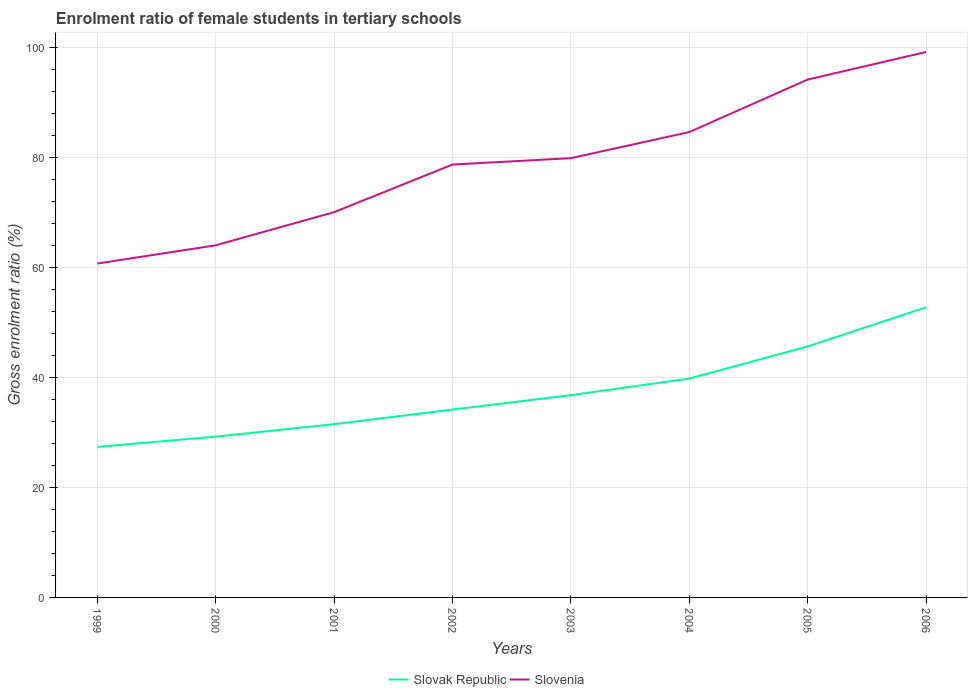How many different coloured lines are there?
Your answer should be compact. 2. Does the line corresponding to Slovak Republic intersect with the line corresponding to Slovenia?
Make the answer very short. No. Across all years, what is the maximum enrolment ratio of female students in tertiary schools in Slovenia?
Make the answer very short. 60.68. In which year was the enrolment ratio of female students in tertiary schools in Slovak Republic maximum?
Your response must be concise. 1999. What is the total enrolment ratio of female students in tertiary schools in Slovenia in the graph?
Make the answer very short. -17.99. What is the difference between the highest and the second highest enrolment ratio of female students in tertiary schools in Slovenia?
Make the answer very short. 38.45. What is the difference between the highest and the lowest enrolment ratio of female students in tertiary schools in Slovak Republic?
Keep it short and to the point. 3. Is the enrolment ratio of female students in tertiary schools in Slovak Republic strictly greater than the enrolment ratio of female students in tertiary schools in Slovenia over the years?
Keep it short and to the point. Yes. How many lines are there?
Provide a short and direct response. 2. How many years are there in the graph?
Offer a very short reply. 8. Does the graph contain any zero values?
Your answer should be very brief. No. How are the legend labels stacked?
Ensure brevity in your answer.  Horizontal. What is the title of the graph?
Give a very brief answer. Enrolment ratio of female students in tertiary schools. Does "Seychelles" appear as one of the legend labels in the graph?
Offer a very short reply. No. What is the label or title of the X-axis?
Ensure brevity in your answer.  Years. What is the Gross enrolment ratio (%) in Slovak Republic in 1999?
Ensure brevity in your answer.  27.36. What is the Gross enrolment ratio (%) of Slovenia in 1999?
Keep it short and to the point. 60.68. What is the Gross enrolment ratio (%) in Slovak Republic in 2000?
Keep it short and to the point. 29.23. What is the Gross enrolment ratio (%) in Slovenia in 2000?
Give a very brief answer. 64. What is the Gross enrolment ratio (%) of Slovak Republic in 2001?
Make the answer very short. 31.49. What is the Gross enrolment ratio (%) of Slovenia in 2001?
Offer a terse response. 70.02. What is the Gross enrolment ratio (%) of Slovak Republic in 2002?
Ensure brevity in your answer.  34.15. What is the Gross enrolment ratio (%) in Slovenia in 2002?
Make the answer very short. 78.68. What is the Gross enrolment ratio (%) in Slovak Republic in 2003?
Provide a succinct answer. 36.76. What is the Gross enrolment ratio (%) in Slovenia in 2003?
Offer a terse response. 79.84. What is the Gross enrolment ratio (%) in Slovak Republic in 2004?
Provide a succinct answer. 39.78. What is the Gross enrolment ratio (%) in Slovenia in 2004?
Offer a very short reply. 84.58. What is the Gross enrolment ratio (%) of Slovak Republic in 2005?
Offer a terse response. 45.62. What is the Gross enrolment ratio (%) of Slovenia in 2005?
Provide a succinct answer. 94.12. What is the Gross enrolment ratio (%) in Slovak Republic in 2006?
Offer a terse response. 52.73. What is the Gross enrolment ratio (%) of Slovenia in 2006?
Give a very brief answer. 99.13. Across all years, what is the maximum Gross enrolment ratio (%) in Slovak Republic?
Provide a succinct answer. 52.73. Across all years, what is the maximum Gross enrolment ratio (%) of Slovenia?
Your answer should be compact. 99.13. Across all years, what is the minimum Gross enrolment ratio (%) of Slovak Republic?
Provide a succinct answer. 27.36. Across all years, what is the minimum Gross enrolment ratio (%) in Slovenia?
Make the answer very short. 60.68. What is the total Gross enrolment ratio (%) in Slovak Republic in the graph?
Offer a very short reply. 297.11. What is the total Gross enrolment ratio (%) of Slovenia in the graph?
Provide a short and direct response. 631.05. What is the difference between the Gross enrolment ratio (%) in Slovak Republic in 1999 and that in 2000?
Your answer should be compact. -1.87. What is the difference between the Gross enrolment ratio (%) of Slovenia in 1999 and that in 2000?
Keep it short and to the point. -3.32. What is the difference between the Gross enrolment ratio (%) in Slovak Republic in 1999 and that in 2001?
Your answer should be compact. -4.14. What is the difference between the Gross enrolment ratio (%) in Slovenia in 1999 and that in 2001?
Make the answer very short. -9.34. What is the difference between the Gross enrolment ratio (%) of Slovak Republic in 1999 and that in 2002?
Keep it short and to the point. -6.79. What is the difference between the Gross enrolment ratio (%) of Slovenia in 1999 and that in 2002?
Ensure brevity in your answer.  -17.99. What is the difference between the Gross enrolment ratio (%) of Slovak Republic in 1999 and that in 2003?
Provide a succinct answer. -9.41. What is the difference between the Gross enrolment ratio (%) in Slovenia in 1999 and that in 2003?
Provide a succinct answer. -19.16. What is the difference between the Gross enrolment ratio (%) in Slovak Republic in 1999 and that in 2004?
Keep it short and to the point. -12.43. What is the difference between the Gross enrolment ratio (%) of Slovenia in 1999 and that in 2004?
Your answer should be very brief. -23.9. What is the difference between the Gross enrolment ratio (%) in Slovak Republic in 1999 and that in 2005?
Provide a succinct answer. -18.26. What is the difference between the Gross enrolment ratio (%) of Slovenia in 1999 and that in 2005?
Give a very brief answer. -33.44. What is the difference between the Gross enrolment ratio (%) in Slovak Republic in 1999 and that in 2006?
Offer a very short reply. -25.37. What is the difference between the Gross enrolment ratio (%) in Slovenia in 1999 and that in 2006?
Ensure brevity in your answer.  -38.45. What is the difference between the Gross enrolment ratio (%) of Slovak Republic in 2000 and that in 2001?
Provide a succinct answer. -2.26. What is the difference between the Gross enrolment ratio (%) of Slovenia in 2000 and that in 2001?
Offer a very short reply. -6.02. What is the difference between the Gross enrolment ratio (%) in Slovak Republic in 2000 and that in 2002?
Your answer should be very brief. -4.92. What is the difference between the Gross enrolment ratio (%) of Slovenia in 2000 and that in 2002?
Your response must be concise. -14.68. What is the difference between the Gross enrolment ratio (%) in Slovak Republic in 2000 and that in 2003?
Provide a succinct answer. -7.53. What is the difference between the Gross enrolment ratio (%) of Slovenia in 2000 and that in 2003?
Provide a short and direct response. -15.84. What is the difference between the Gross enrolment ratio (%) in Slovak Republic in 2000 and that in 2004?
Provide a succinct answer. -10.55. What is the difference between the Gross enrolment ratio (%) of Slovenia in 2000 and that in 2004?
Ensure brevity in your answer.  -20.58. What is the difference between the Gross enrolment ratio (%) in Slovak Republic in 2000 and that in 2005?
Offer a very short reply. -16.39. What is the difference between the Gross enrolment ratio (%) in Slovenia in 2000 and that in 2005?
Your response must be concise. -30.12. What is the difference between the Gross enrolment ratio (%) in Slovak Republic in 2000 and that in 2006?
Offer a very short reply. -23.5. What is the difference between the Gross enrolment ratio (%) in Slovenia in 2000 and that in 2006?
Your response must be concise. -35.13. What is the difference between the Gross enrolment ratio (%) of Slovak Republic in 2001 and that in 2002?
Your answer should be very brief. -2.65. What is the difference between the Gross enrolment ratio (%) in Slovenia in 2001 and that in 2002?
Your response must be concise. -8.65. What is the difference between the Gross enrolment ratio (%) in Slovak Republic in 2001 and that in 2003?
Provide a succinct answer. -5.27. What is the difference between the Gross enrolment ratio (%) of Slovenia in 2001 and that in 2003?
Make the answer very short. -9.82. What is the difference between the Gross enrolment ratio (%) of Slovak Republic in 2001 and that in 2004?
Keep it short and to the point. -8.29. What is the difference between the Gross enrolment ratio (%) in Slovenia in 2001 and that in 2004?
Ensure brevity in your answer.  -14.56. What is the difference between the Gross enrolment ratio (%) in Slovak Republic in 2001 and that in 2005?
Your response must be concise. -14.13. What is the difference between the Gross enrolment ratio (%) in Slovenia in 2001 and that in 2005?
Provide a succinct answer. -24.1. What is the difference between the Gross enrolment ratio (%) of Slovak Republic in 2001 and that in 2006?
Offer a terse response. -21.24. What is the difference between the Gross enrolment ratio (%) in Slovenia in 2001 and that in 2006?
Your response must be concise. -29.11. What is the difference between the Gross enrolment ratio (%) of Slovak Republic in 2002 and that in 2003?
Provide a short and direct response. -2.62. What is the difference between the Gross enrolment ratio (%) in Slovenia in 2002 and that in 2003?
Your answer should be very brief. -1.16. What is the difference between the Gross enrolment ratio (%) of Slovak Republic in 2002 and that in 2004?
Make the answer very short. -5.64. What is the difference between the Gross enrolment ratio (%) of Slovenia in 2002 and that in 2004?
Provide a succinct answer. -5.9. What is the difference between the Gross enrolment ratio (%) in Slovak Republic in 2002 and that in 2005?
Provide a short and direct response. -11.47. What is the difference between the Gross enrolment ratio (%) of Slovenia in 2002 and that in 2005?
Offer a very short reply. -15.44. What is the difference between the Gross enrolment ratio (%) in Slovak Republic in 2002 and that in 2006?
Provide a short and direct response. -18.58. What is the difference between the Gross enrolment ratio (%) of Slovenia in 2002 and that in 2006?
Give a very brief answer. -20.46. What is the difference between the Gross enrolment ratio (%) of Slovak Republic in 2003 and that in 2004?
Provide a short and direct response. -3.02. What is the difference between the Gross enrolment ratio (%) in Slovenia in 2003 and that in 2004?
Offer a very short reply. -4.74. What is the difference between the Gross enrolment ratio (%) in Slovak Republic in 2003 and that in 2005?
Provide a succinct answer. -8.86. What is the difference between the Gross enrolment ratio (%) in Slovenia in 2003 and that in 2005?
Make the answer very short. -14.28. What is the difference between the Gross enrolment ratio (%) in Slovak Republic in 2003 and that in 2006?
Keep it short and to the point. -15.97. What is the difference between the Gross enrolment ratio (%) of Slovenia in 2003 and that in 2006?
Your answer should be compact. -19.29. What is the difference between the Gross enrolment ratio (%) of Slovak Republic in 2004 and that in 2005?
Give a very brief answer. -5.84. What is the difference between the Gross enrolment ratio (%) in Slovenia in 2004 and that in 2005?
Offer a terse response. -9.54. What is the difference between the Gross enrolment ratio (%) in Slovak Republic in 2004 and that in 2006?
Offer a terse response. -12.95. What is the difference between the Gross enrolment ratio (%) in Slovenia in 2004 and that in 2006?
Your response must be concise. -14.55. What is the difference between the Gross enrolment ratio (%) in Slovak Republic in 2005 and that in 2006?
Keep it short and to the point. -7.11. What is the difference between the Gross enrolment ratio (%) in Slovenia in 2005 and that in 2006?
Give a very brief answer. -5.01. What is the difference between the Gross enrolment ratio (%) in Slovak Republic in 1999 and the Gross enrolment ratio (%) in Slovenia in 2000?
Your response must be concise. -36.64. What is the difference between the Gross enrolment ratio (%) in Slovak Republic in 1999 and the Gross enrolment ratio (%) in Slovenia in 2001?
Your answer should be very brief. -42.67. What is the difference between the Gross enrolment ratio (%) in Slovak Republic in 1999 and the Gross enrolment ratio (%) in Slovenia in 2002?
Ensure brevity in your answer.  -51.32. What is the difference between the Gross enrolment ratio (%) of Slovak Republic in 1999 and the Gross enrolment ratio (%) of Slovenia in 2003?
Provide a short and direct response. -52.48. What is the difference between the Gross enrolment ratio (%) of Slovak Republic in 1999 and the Gross enrolment ratio (%) of Slovenia in 2004?
Ensure brevity in your answer.  -57.22. What is the difference between the Gross enrolment ratio (%) of Slovak Republic in 1999 and the Gross enrolment ratio (%) of Slovenia in 2005?
Give a very brief answer. -66.77. What is the difference between the Gross enrolment ratio (%) of Slovak Republic in 1999 and the Gross enrolment ratio (%) of Slovenia in 2006?
Your answer should be compact. -71.78. What is the difference between the Gross enrolment ratio (%) in Slovak Republic in 2000 and the Gross enrolment ratio (%) in Slovenia in 2001?
Your answer should be compact. -40.8. What is the difference between the Gross enrolment ratio (%) in Slovak Republic in 2000 and the Gross enrolment ratio (%) in Slovenia in 2002?
Offer a very short reply. -49.45. What is the difference between the Gross enrolment ratio (%) in Slovak Republic in 2000 and the Gross enrolment ratio (%) in Slovenia in 2003?
Offer a terse response. -50.61. What is the difference between the Gross enrolment ratio (%) in Slovak Republic in 2000 and the Gross enrolment ratio (%) in Slovenia in 2004?
Your answer should be compact. -55.35. What is the difference between the Gross enrolment ratio (%) in Slovak Republic in 2000 and the Gross enrolment ratio (%) in Slovenia in 2005?
Offer a terse response. -64.89. What is the difference between the Gross enrolment ratio (%) in Slovak Republic in 2000 and the Gross enrolment ratio (%) in Slovenia in 2006?
Offer a terse response. -69.91. What is the difference between the Gross enrolment ratio (%) of Slovak Republic in 2001 and the Gross enrolment ratio (%) of Slovenia in 2002?
Give a very brief answer. -47.18. What is the difference between the Gross enrolment ratio (%) in Slovak Republic in 2001 and the Gross enrolment ratio (%) in Slovenia in 2003?
Your response must be concise. -48.35. What is the difference between the Gross enrolment ratio (%) of Slovak Republic in 2001 and the Gross enrolment ratio (%) of Slovenia in 2004?
Your answer should be compact. -53.09. What is the difference between the Gross enrolment ratio (%) of Slovak Republic in 2001 and the Gross enrolment ratio (%) of Slovenia in 2005?
Offer a very short reply. -62.63. What is the difference between the Gross enrolment ratio (%) of Slovak Republic in 2001 and the Gross enrolment ratio (%) of Slovenia in 2006?
Make the answer very short. -67.64. What is the difference between the Gross enrolment ratio (%) in Slovak Republic in 2002 and the Gross enrolment ratio (%) in Slovenia in 2003?
Keep it short and to the point. -45.69. What is the difference between the Gross enrolment ratio (%) of Slovak Republic in 2002 and the Gross enrolment ratio (%) of Slovenia in 2004?
Your answer should be compact. -50.43. What is the difference between the Gross enrolment ratio (%) in Slovak Republic in 2002 and the Gross enrolment ratio (%) in Slovenia in 2005?
Offer a terse response. -59.98. What is the difference between the Gross enrolment ratio (%) of Slovak Republic in 2002 and the Gross enrolment ratio (%) of Slovenia in 2006?
Offer a very short reply. -64.99. What is the difference between the Gross enrolment ratio (%) in Slovak Republic in 2003 and the Gross enrolment ratio (%) in Slovenia in 2004?
Your answer should be compact. -47.82. What is the difference between the Gross enrolment ratio (%) of Slovak Republic in 2003 and the Gross enrolment ratio (%) of Slovenia in 2005?
Offer a terse response. -57.36. What is the difference between the Gross enrolment ratio (%) of Slovak Republic in 2003 and the Gross enrolment ratio (%) of Slovenia in 2006?
Your answer should be compact. -62.37. What is the difference between the Gross enrolment ratio (%) of Slovak Republic in 2004 and the Gross enrolment ratio (%) of Slovenia in 2005?
Offer a terse response. -54.34. What is the difference between the Gross enrolment ratio (%) of Slovak Republic in 2004 and the Gross enrolment ratio (%) of Slovenia in 2006?
Keep it short and to the point. -59.35. What is the difference between the Gross enrolment ratio (%) of Slovak Republic in 2005 and the Gross enrolment ratio (%) of Slovenia in 2006?
Keep it short and to the point. -53.51. What is the average Gross enrolment ratio (%) in Slovak Republic per year?
Offer a very short reply. 37.14. What is the average Gross enrolment ratio (%) in Slovenia per year?
Your response must be concise. 78.88. In the year 1999, what is the difference between the Gross enrolment ratio (%) in Slovak Republic and Gross enrolment ratio (%) in Slovenia?
Your response must be concise. -33.33. In the year 2000, what is the difference between the Gross enrolment ratio (%) in Slovak Republic and Gross enrolment ratio (%) in Slovenia?
Your answer should be compact. -34.77. In the year 2001, what is the difference between the Gross enrolment ratio (%) in Slovak Republic and Gross enrolment ratio (%) in Slovenia?
Your answer should be very brief. -38.53. In the year 2002, what is the difference between the Gross enrolment ratio (%) of Slovak Republic and Gross enrolment ratio (%) of Slovenia?
Your answer should be compact. -44.53. In the year 2003, what is the difference between the Gross enrolment ratio (%) of Slovak Republic and Gross enrolment ratio (%) of Slovenia?
Your answer should be compact. -43.08. In the year 2004, what is the difference between the Gross enrolment ratio (%) of Slovak Republic and Gross enrolment ratio (%) of Slovenia?
Your response must be concise. -44.8. In the year 2005, what is the difference between the Gross enrolment ratio (%) in Slovak Republic and Gross enrolment ratio (%) in Slovenia?
Give a very brief answer. -48.5. In the year 2006, what is the difference between the Gross enrolment ratio (%) of Slovak Republic and Gross enrolment ratio (%) of Slovenia?
Give a very brief answer. -46.41. What is the ratio of the Gross enrolment ratio (%) of Slovak Republic in 1999 to that in 2000?
Your answer should be compact. 0.94. What is the ratio of the Gross enrolment ratio (%) of Slovenia in 1999 to that in 2000?
Your answer should be compact. 0.95. What is the ratio of the Gross enrolment ratio (%) in Slovak Republic in 1999 to that in 2001?
Offer a terse response. 0.87. What is the ratio of the Gross enrolment ratio (%) in Slovenia in 1999 to that in 2001?
Your response must be concise. 0.87. What is the ratio of the Gross enrolment ratio (%) of Slovak Republic in 1999 to that in 2002?
Provide a short and direct response. 0.8. What is the ratio of the Gross enrolment ratio (%) in Slovenia in 1999 to that in 2002?
Ensure brevity in your answer.  0.77. What is the ratio of the Gross enrolment ratio (%) in Slovak Republic in 1999 to that in 2003?
Make the answer very short. 0.74. What is the ratio of the Gross enrolment ratio (%) of Slovenia in 1999 to that in 2003?
Your answer should be compact. 0.76. What is the ratio of the Gross enrolment ratio (%) of Slovak Republic in 1999 to that in 2004?
Ensure brevity in your answer.  0.69. What is the ratio of the Gross enrolment ratio (%) in Slovenia in 1999 to that in 2004?
Offer a terse response. 0.72. What is the ratio of the Gross enrolment ratio (%) in Slovak Republic in 1999 to that in 2005?
Provide a short and direct response. 0.6. What is the ratio of the Gross enrolment ratio (%) of Slovenia in 1999 to that in 2005?
Make the answer very short. 0.64. What is the ratio of the Gross enrolment ratio (%) in Slovak Republic in 1999 to that in 2006?
Your answer should be very brief. 0.52. What is the ratio of the Gross enrolment ratio (%) in Slovenia in 1999 to that in 2006?
Offer a terse response. 0.61. What is the ratio of the Gross enrolment ratio (%) in Slovak Republic in 2000 to that in 2001?
Your answer should be compact. 0.93. What is the ratio of the Gross enrolment ratio (%) of Slovenia in 2000 to that in 2001?
Make the answer very short. 0.91. What is the ratio of the Gross enrolment ratio (%) of Slovak Republic in 2000 to that in 2002?
Provide a short and direct response. 0.86. What is the ratio of the Gross enrolment ratio (%) in Slovenia in 2000 to that in 2002?
Offer a terse response. 0.81. What is the ratio of the Gross enrolment ratio (%) of Slovak Republic in 2000 to that in 2003?
Make the answer very short. 0.8. What is the ratio of the Gross enrolment ratio (%) in Slovenia in 2000 to that in 2003?
Provide a succinct answer. 0.8. What is the ratio of the Gross enrolment ratio (%) of Slovak Republic in 2000 to that in 2004?
Your answer should be compact. 0.73. What is the ratio of the Gross enrolment ratio (%) of Slovenia in 2000 to that in 2004?
Offer a terse response. 0.76. What is the ratio of the Gross enrolment ratio (%) of Slovak Republic in 2000 to that in 2005?
Your answer should be very brief. 0.64. What is the ratio of the Gross enrolment ratio (%) of Slovenia in 2000 to that in 2005?
Give a very brief answer. 0.68. What is the ratio of the Gross enrolment ratio (%) in Slovak Republic in 2000 to that in 2006?
Offer a terse response. 0.55. What is the ratio of the Gross enrolment ratio (%) in Slovenia in 2000 to that in 2006?
Offer a terse response. 0.65. What is the ratio of the Gross enrolment ratio (%) in Slovak Republic in 2001 to that in 2002?
Ensure brevity in your answer.  0.92. What is the ratio of the Gross enrolment ratio (%) of Slovenia in 2001 to that in 2002?
Keep it short and to the point. 0.89. What is the ratio of the Gross enrolment ratio (%) of Slovak Republic in 2001 to that in 2003?
Keep it short and to the point. 0.86. What is the ratio of the Gross enrolment ratio (%) of Slovenia in 2001 to that in 2003?
Provide a succinct answer. 0.88. What is the ratio of the Gross enrolment ratio (%) of Slovak Republic in 2001 to that in 2004?
Offer a very short reply. 0.79. What is the ratio of the Gross enrolment ratio (%) in Slovenia in 2001 to that in 2004?
Your answer should be compact. 0.83. What is the ratio of the Gross enrolment ratio (%) in Slovak Republic in 2001 to that in 2005?
Your response must be concise. 0.69. What is the ratio of the Gross enrolment ratio (%) of Slovenia in 2001 to that in 2005?
Provide a short and direct response. 0.74. What is the ratio of the Gross enrolment ratio (%) of Slovak Republic in 2001 to that in 2006?
Your answer should be very brief. 0.6. What is the ratio of the Gross enrolment ratio (%) of Slovenia in 2001 to that in 2006?
Make the answer very short. 0.71. What is the ratio of the Gross enrolment ratio (%) in Slovak Republic in 2002 to that in 2003?
Offer a terse response. 0.93. What is the ratio of the Gross enrolment ratio (%) of Slovenia in 2002 to that in 2003?
Your answer should be compact. 0.99. What is the ratio of the Gross enrolment ratio (%) in Slovak Republic in 2002 to that in 2004?
Provide a short and direct response. 0.86. What is the ratio of the Gross enrolment ratio (%) in Slovenia in 2002 to that in 2004?
Make the answer very short. 0.93. What is the ratio of the Gross enrolment ratio (%) in Slovak Republic in 2002 to that in 2005?
Offer a very short reply. 0.75. What is the ratio of the Gross enrolment ratio (%) in Slovenia in 2002 to that in 2005?
Give a very brief answer. 0.84. What is the ratio of the Gross enrolment ratio (%) in Slovak Republic in 2002 to that in 2006?
Your answer should be compact. 0.65. What is the ratio of the Gross enrolment ratio (%) of Slovenia in 2002 to that in 2006?
Your answer should be compact. 0.79. What is the ratio of the Gross enrolment ratio (%) of Slovak Republic in 2003 to that in 2004?
Ensure brevity in your answer.  0.92. What is the ratio of the Gross enrolment ratio (%) of Slovenia in 2003 to that in 2004?
Offer a terse response. 0.94. What is the ratio of the Gross enrolment ratio (%) of Slovak Republic in 2003 to that in 2005?
Your answer should be very brief. 0.81. What is the ratio of the Gross enrolment ratio (%) of Slovenia in 2003 to that in 2005?
Your answer should be compact. 0.85. What is the ratio of the Gross enrolment ratio (%) of Slovak Republic in 2003 to that in 2006?
Provide a succinct answer. 0.7. What is the ratio of the Gross enrolment ratio (%) of Slovenia in 2003 to that in 2006?
Provide a succinct answer. 0.81. What is the ratio of the Gross enrolment ratio (%) in Slovak Republic in 2004 to that in 2005?
Ensure brevity in your answer.  0.87. What is the ratio of the Gross enrolment ratio (%) in Slovenia in 2004 to that in 2005?
Your response must be concise. 0.9. What is the ratio of the Gross enrolment ratio (%) of Slovak Republic in 2004 to that in 2006?
Provide a succinct answer. 0.75. What is the ratio of the Gross enrolment ratio (%) of Slovenia in 2004 to that in 2006?
Your response must be concise. 0.85. What is the ratio of the Gross enrolment ratio (%) in Slovak Republic in 2005 to that in 2006?
Give a very brief answer. 0.87. What is the ratio of the Gross enrolment ratio (%) of Slovenia in 2005 to that in 2006?
Your answer should be very brief. 0.95. What is the difference between the highest and the second highest Gross enrolment ratio (%) of Slovak Republic?
Provide a short and direct response. 7.11. What is the difference between the highest and the second highest Gross enrolment ratio (%) in Slovenia?
Your response must be concise. 5.01. What is the difference between the highest and the lowest Gross enrolment ratio (%) in Slovak Republic?
Offer a very short reply. 25.37. What is the difference between the highest and the lowest Gross enrolment ratio (%) of Slovenia?
Your answer should be compact. 38.45. 